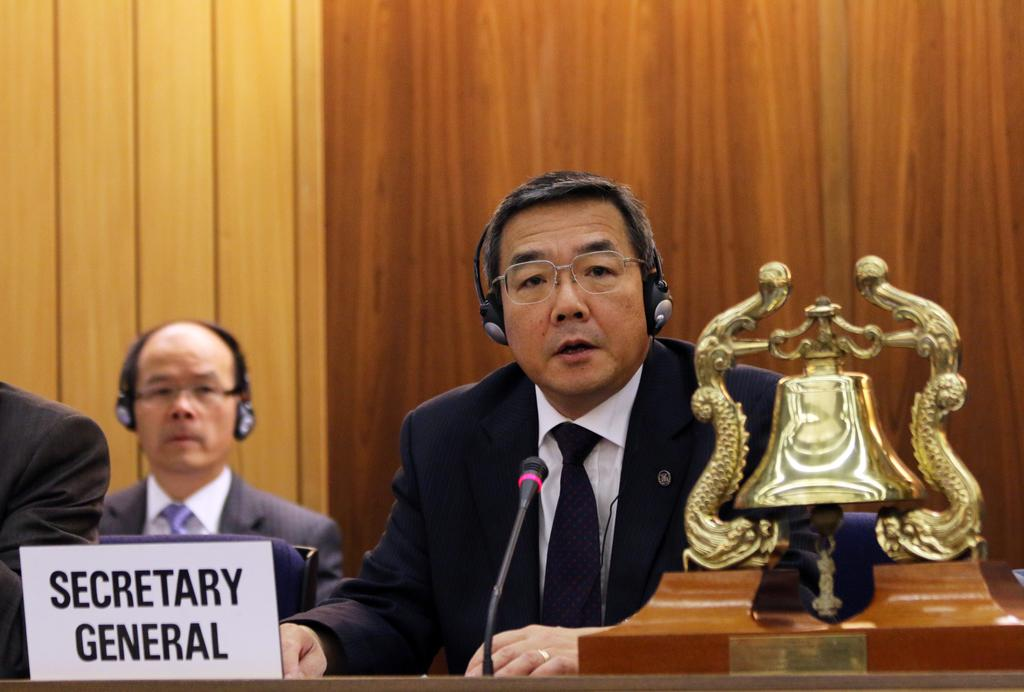What are the people in the image doing? The persons sitting at the table in the image are likely engaged in a discussion or meeting. What object on the table can be used for identification? There is a name board on the table, which may be used for identification purposes. What device on the table is used for amplifying sound? There is a mic on the table, which is used for amplifying sound. What object on the table can be used for signaling or attracting attention? There is a bell on the table, which can be used for signaling or attracting attention. What can be seen in the background of the image? There is a wall in the background of the image. What is the value of the trip mentioned on the name board in the image? There is no trip or value mentioned on the name board in the image; it is used for identification purposes. 